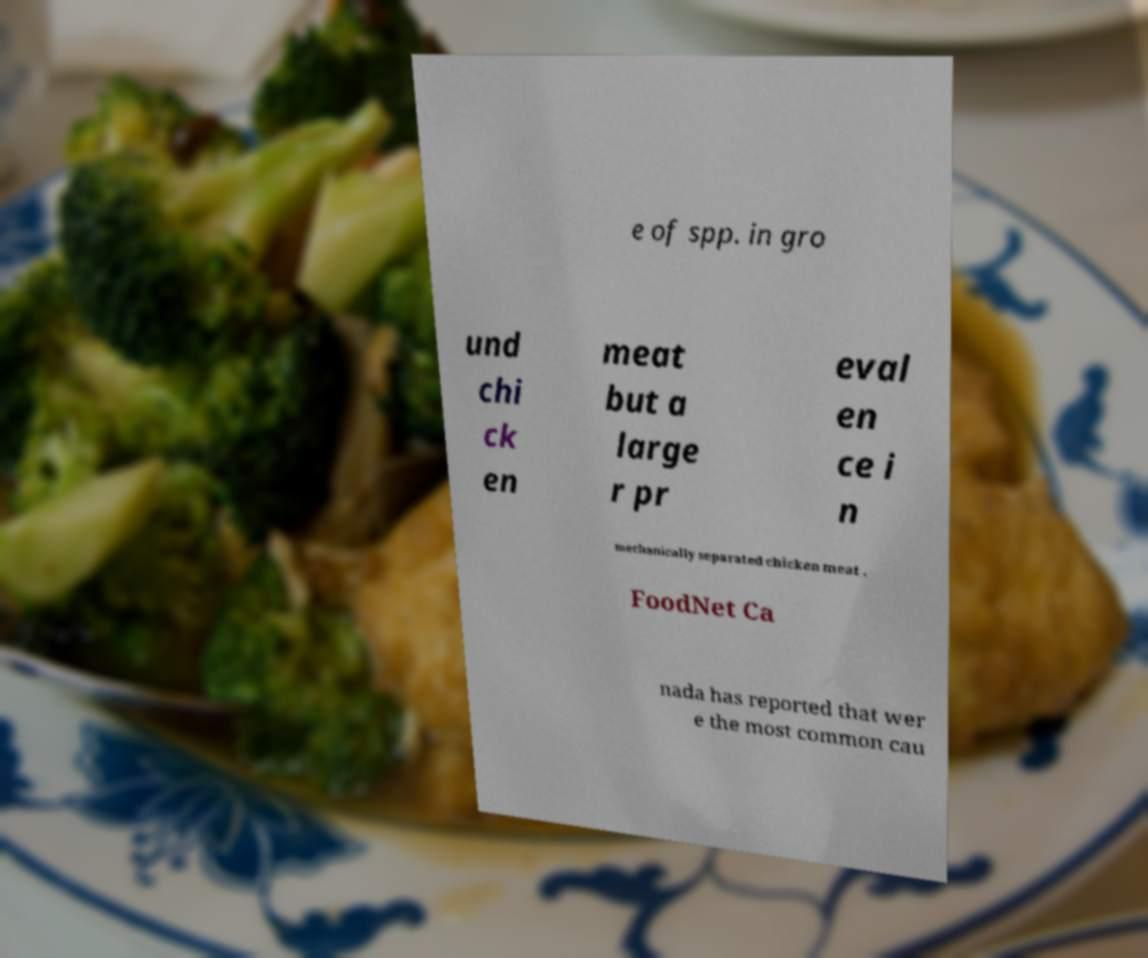I need the written content from this picture converted into text. Can you do that? e of spp. in gro und chi ck en meat but a large r pr eval en ce i n mechanically separated chicken meat . FoodNet Ca nada has reported that wer e the most common cau 